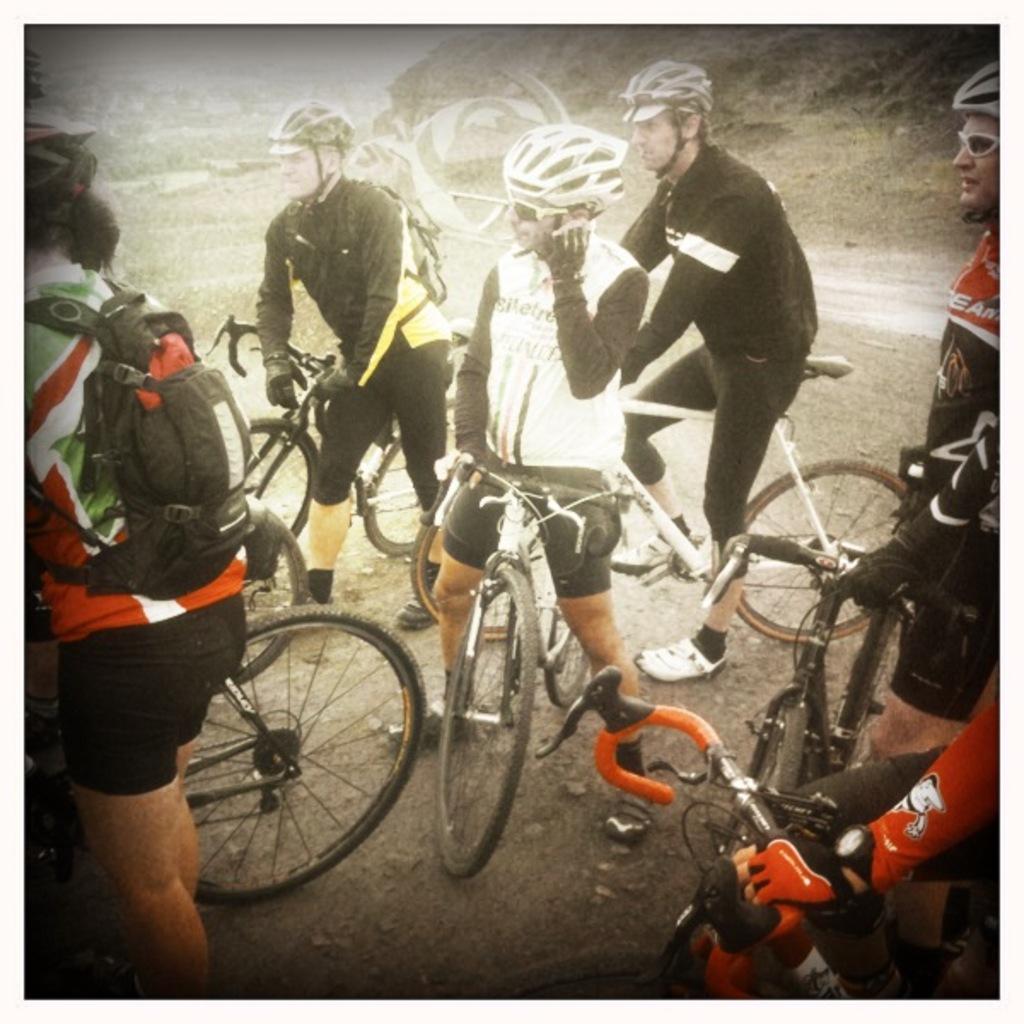Could you give a brief overview of what you see in this image? In this image I see number of persons and they are with the cycles. 